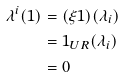<formula> <loc_0><loc_0><loc_500><loc_500>\lambda ^ { i } ( 1 ) & = ( \xi 1 ) ( \lambda _ { i } ) \\ & = 1 _ { U R } ( \lambda _ { i } ) \\ & = 0</formula> 